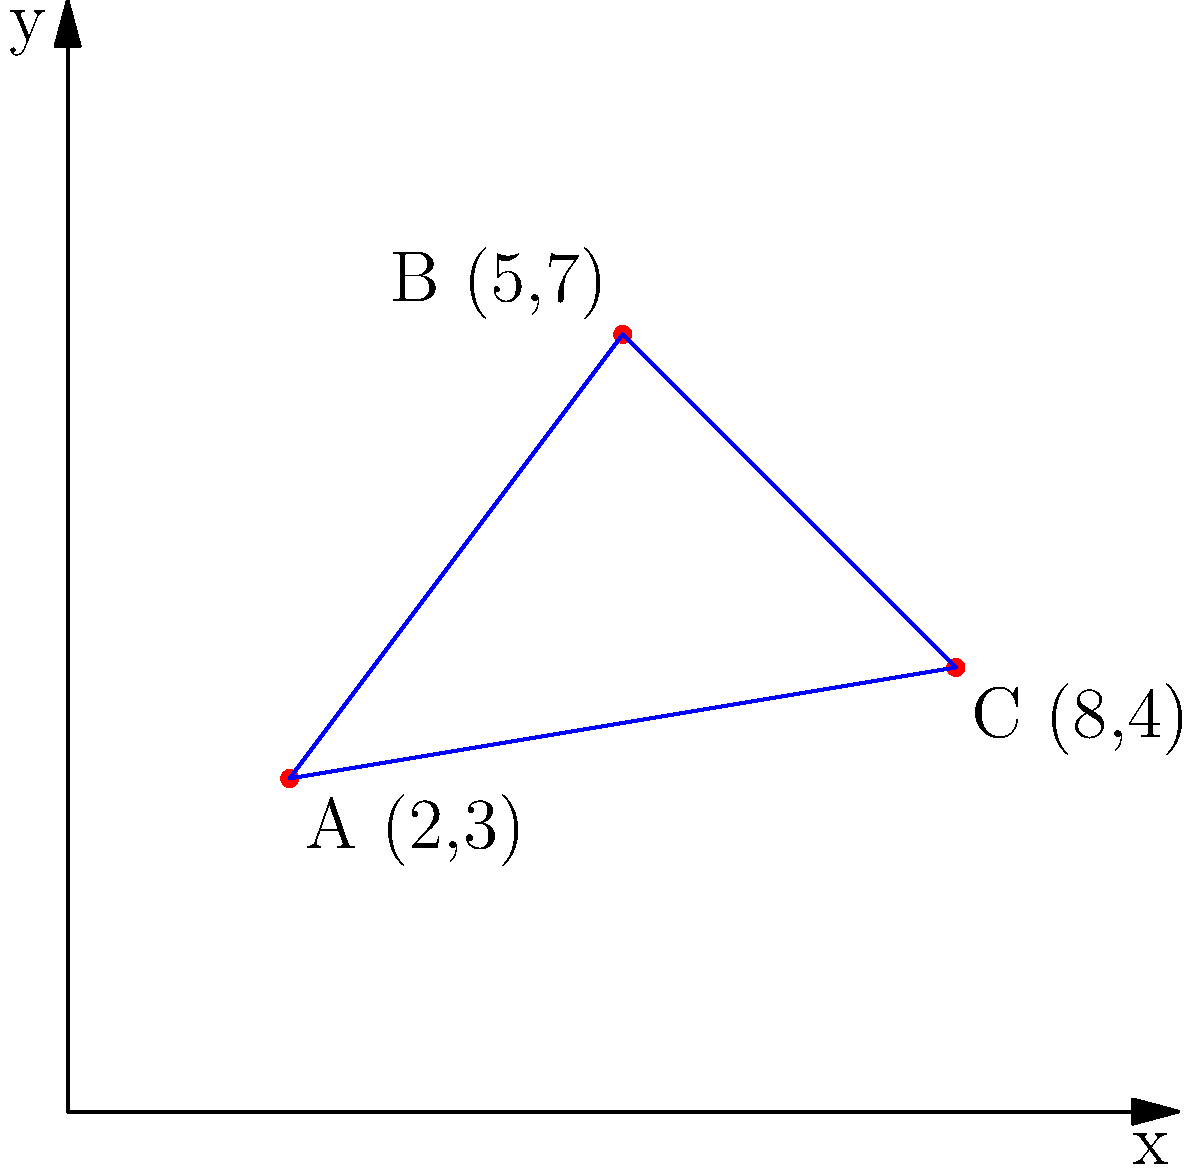As the postmaster general, you're tasked with optimizing mail delivery routes. Given three delivery points A(2,3), B(5,7), and C(8,4) on a Cartesian coordinate system representing a city grid, what is the total distance (in grid units) of the most efficient route that visits all three points and returns to the starting point? Round your answer to two decimal places. To find the most efficient route, we need to calculate the distances between all points and choose the shortest path. Let's approach this step-by-step:

1. Calculate the distances between each pair of points using the distance formula:
   $d = \sqrt{(x_2-x_1)^2 + (y_2-y_1)^2}$

   AB: $\sqrt{(5-2)^2 + (7-3)^2} = \sqrt{3^2 + 4^2} = \sqrt{25} = 5$
   BC: $\sqrt{(8-5)^2 + (4-7)^2} = \sqrt{3^2 + (-3)^2} = \sqrt{18} \approx 4.24$
   CA: $\sqrt{(2-8)^2 + (3-4)^2} = \sqrt{(-6)^2 + (-1)^2} = \sqrt{37} \approx 6.08$

2. The total route distance will be the sum of these three distances, as we need to return to the starting point.

3. Calculate the total distance:
   Total distance = AB + BC + CA = 5 + 4.24 + 6.08 = 15.32

4. Round to two decimal places: 15.32

This route (A -> B -> C -> A or its reverse) is the most efficient because it visits each point once and returns to the start, minimizing the total distance traveled.
Answer: 15.32 grid units 